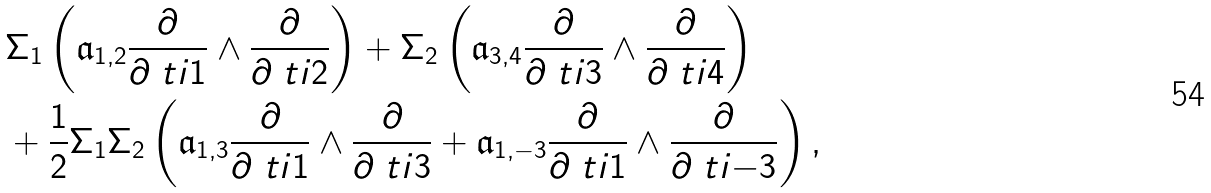<formula> <loc_0><loc_0><loc_500><loc_500>& \Sigma _ { 1 } \left ( \mathfrak { a } _ { 1 , 2 } \frac { \partial } { \partial \ t i { 1 } } \land \frac { \partial } { \partial \ t i { 2 } } \right ) + \Sigma _ { 2 } \left ( \mathfrak { a } _ { 3 , 4 } \frac { \partial } { \partial \ t i { 3 } } \land \frac { \partial } { \partial \ t i { 4 } } \right ) \\ & + \frac { 1 } { 2 } \Sigma _ { 1 } \Sigma _ { 2 } \left ( \mathfrak { a } _ { 1 , 3 } \frac { \partial } { \partial \ t i { 1 } } \land \frac { \partial } { \partial \ t i { 3 } } + \mathfrak { a } _ { 1 , - 3 } \frac { \partial } { \partial \ t i { 1 } } \land \frac { \partial } { \partial \ t i { - 3 } } \right ) ,</formula> 